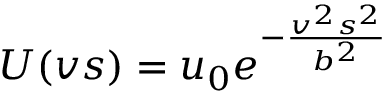<formula> <loc_0><loc_0><loc_500><loc_500>U ( v s ) = u _ { 0 } e ^ { - \frac { v ^ { 2 } s ^ { 2 } } { b ^ { 2 } } }</formula> 